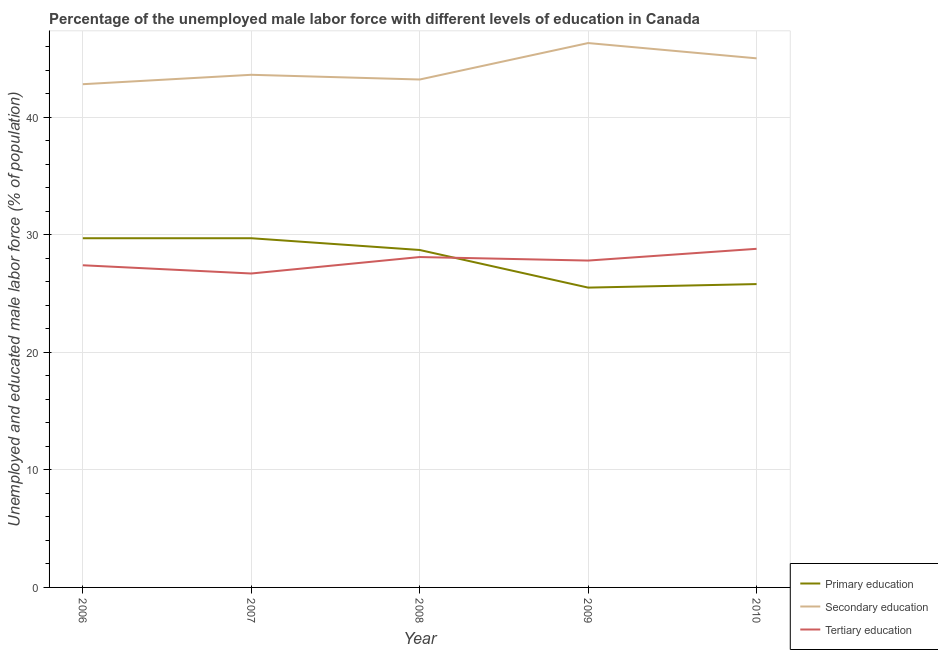How many different coloured lines are there?
Your answer should be very brief. 3. Is the number of lines equal to the number of legend labels?
Your response must be concise. Yes. What is the percentage of male labor force who received tertiary education in 2008?
Give a very brief answer. 28.1. Across all years, what is the maximum percentage of male labor force who received tertiary education?
Your answer should be very brief. 28.8. Across all years, what is the minimum percentage of male labor force who received tertiary education?
Give a very brief answer. 26.7. What is the total percentage of male labor force who received tertiary education in the graph?
Ensure brevity in your answer.  138.8. What is the difference between the percentage of male labor force who received secondary education in 2006 and that in 2007?
Your answer should be very brief. -0.8. What is the difference between the percentage of male labor force who received secondary education in 2007 and the percentage of male labor force who received primary education in 2010?
Give a very brief answer. 17.8. What is the average percentage of male labor force who received tertiary education per year?
Your response must be concise. 27.76. In the year 2010, what is the difference between the percentage of male labor force who received secondary education and percentage of male labor force who received primary education?
Give a very brief answer. 19.2. What is the ratio of the percentage of male labor force who received tertiary education in 2008 to that in 2009?
Your response must be concise. 1.01. Is the percentage of male labor force who received tertiary education in 2006 less than that in 2009?
Provide a short and direct response. Yes. What is the difference between the highest and the second highest percentage of male labor force who received secondary education?
Provide a succinct answer. 1.3. What is the difference between the highest and the lowest percentage of male labor force who received tertiary education?
Your response must be concise. 2.1. Is the sum of the percentage of male labor force who received secondary education in 2008 and 2010 greater than the maximum percentage of male labor force who received tertiary education across all years?
Offer a very short reply. Yes. Is the percentage of male labor force who received tertiary education strictly less than the percentage of male labor force who received primary education over the years?
Keep it short and to the point. No. How many lines are there?
Your answer should be compact. 3. How many years are there in the graph?
Keep it short and to the point. 5. Does the graph contain any zero values?
Your response must be concise. No. How are the legend labels stacked?
Your response must be concise. Vertical. What is the title of the graph?
Ensure brevity in your answer.  Percentage of the unemployed male labor force with different levels of education in Canada. What is the label or title of the X-axis?
Ensure brevity in your answer.  Year. What is the label or title of the Y-axis?
Offer a very short reply. Unemployed and educated male labor force (% of population). What is the Unemployed and educated male labor force (% of population) of Primary education in 2006?
Your answer should be very brief. 29.7. What is the Unemployed and educated male labor force (% of population) of Secondary education in 2006?
Your answer should be very brief. 42.8. What is the Unemployed and educated male labor force (% of population) in Tertiary education in 2006?
Offer a terse response. 27.4. What is the Unemployed and educated male labor force (% of population) of Primary education in 2007?
Your answer should be compact. 29.7. What is the Unemployed and educated male labor force (% of population) in Secondary education in 2007?
Ensure brevity in your answer.  43.6. What is the Unemployed and educated male labor force (% of population) in Tertiary education in 2007?
Ensure brevity in your answer.  26.7. What is the Unemployed and educated male labor force (% of population) of Primary education in 2008?
Give a very brief answer. 28.7. What is the Unemployed and educated male labor force (% of population) in Secondary education in 2008?
Your answer should be compact. 43.2. What is the Unemployed and educated male labor force (% of population) of Tertiary education in 2008?
Offer a terse response. 28.1. What is the Unemployed and educated male labor force (% of population) of Primary education in 2009?
Offer a terse response. 25.5. What is the Unemployed and educated male labor force (% of population) in Secondary education in 2009?
Give a very brief answer. 46.3. What is the Unemployed and educated male labor force (% of population) of Tertiary education in 2009?
Provide a short and direct response. 27.8. What is the Unemployed and educated male labor force (% of population) of Primary education in 2010?
Your answer should be very brief. 25.8. What is the Unemployed and educated male labor force (% of population) in Tertiary education in 2010?
Provide a succinct answer. 28.8. Across all years, what is the maximum Unemployed and educated male labor force (% of population) in Primary education?
Ensure brevity in your answer.  29.7. Across all years, what is the maximum Unemployed and educated male labor force (% of population) in Secondary education?
Provide a succinct answer. 46.3. Across all years, what is the maximum Unemployed and educated male labor force (% of population) of Tertiary education?
Provide a short and direct response. 28.8. Across all years, what is the minimum Unemployed and educated male labor force (% of population) of Secondary education?
Your answer should be very brief. 42.8. Across all years, what is the minimum Unemployed and educated male labor force (% of population) in Tertiary education?
Make the answer very short. 26.7. What is the total Unemployed and educated male labor force (% of population) of Primary education in the graph?
Your answer should be compact. 139.4. What is the total Unemployed and educated male labor force (% of population) of Secondary education in the graph?
Offer a terse response. 220.9. What is the total Unemployed and educated male labor force (% of population) of Tertiary education in the graph?
Offer a very short reply. 138.8. What is the difference between the Unemployed and educated male labor force (% of population) of Secondary education in 2006 and that in 2007?
Your answer should be compact. -0.8. What is the difference between the Unemployed and educated male labor force (% of population) in Secondary education in 2006 and that in 2009?
Ensure brevity in your answer.  -3.5. What is the difference between the Unemployed and educated male labor force (% of population) in Primary education in 2007 and that in 2008?
Provide a succinct answer. 1. What is the difference between the Unemployed and educated male labor force (% of population) in Tertiary education in 2007 and that in 2008?
Make the answer very short. -1.4. What is the difference between the Unemployed and educated male labor force (% of population) in Secondary education in 2007 and that in 2009?
Offer a very short reply. -2.7. What is the difference between the Unemployed and educated male labor force (% of population) of Tertiary education in 2007 and that in 2010?
Your answer should be very brief. -2.1. What is the difference between the Unemployed and educated male labor force (% of population) in Primary education in 2008 and that in 2009?
Give a very brief answer. 3.2. What is the difference between the Unemployed and educated male labor force (% of population) in Tertiary education in 2008 and that in 2009?
Your answer should be compact. 0.3. What is the difference between the Unemployed and educated male labor force (% of population) in Tertiary education in 2008 and that in 2010?
Offer a terse response. -0.7. What is the difference between the Unemployed and educated male labor force (% of population) of Secondary education in 2009 and that in 2010?
Give a very brief answer. 1.3. What is the difference between the Unemployed and educated male labor force (% of population) in Primary education in 2006 and the Unemployed and educated male labor force (% of population) in Tertiary education in 2007?
Offer a very short reply. 3. What is the difference between the Unemployed and educated male labor force (% of population) in Primary education in 2006 and the Unemployed and educated male labor force (% of population) in Secondary education in 2008?
Provide a succinct answer. -13.5. What is the difference between the Unemployed and educated male labor force (% of population) of Primary education in 2006 and the Unemployed and educated male labor force (% of population) of Tertiary education in 2008?
Your answer should be very brief. 1.6. What is the difference between the Unemployed and educated male labor force (% of population) in Secondary education in 2006 and the Unemployed and educated male labor force (% of population) in Tertiary education in 2008?
Your response must be concise. 14.7. What is the difference between the Unemployed and educated male labor force (% of population) of Primary education in 2006 and the Unemployed and educated male labor force (% of population) of Secondary education in 2009?
Give a very brief answer. -16.6. What is the difference between the Unemployed and educated male labor force (% of population) in Primary education in 2006 and the Unemployed and educated male labor force (% of population) in Tertiary education in 2009?
Offer a terse response. 1.9. What is the difference between the Unemployed and educated male labor force (% of population) in Primary education in 2006 and the Unemployed and educated male labor force (% of population) in Secondary education in 2010?
Offer a terse response. -15.3. What is the difference between the Unemployed and educated male labor force (% of population) in Primary education in 2006 and the Unemployed and educated male labor force (% of population) in Tertiary education in 2010?
Your response must be concise. 0.9. What is the difference between the Unemployed and educated male labor force (% of population) in Secondary education in 2007 and the Unemployed and educated male labor force (% of population) in Tertiary education in 2008?
Ensure brevity in your answer.  15.5. What is the difference between the Unemployed and educated male labor force (% of population) in Primary education in 2007 and the Unemployed and educated male labor force (% of population) in Secondary education in 2009?
Keep it short and to the point. -16.6. What is the difference between the Unemployed and educated male labor force (% of population) in Primary education in 2007 and the Unemployed and educated male labor force (% of population) in Tertiary education in 2009?
Your answer should be very brief. 1.9. What is the difference between the Unemployed and educated male labor force (% of population) of Primary education in 2007 and the Unemployed and educated male labor force (% of population) of Secondary education in 2010?
Give a very brief answer. -15.3. What is the difference between the Unemployed and educated male labor force (% of population) in Primary education in 2007 and the Unemployed and educated male labor force (% of population) in Tertiary education in 2010?
Offer a very short reply. 0.9. What is the difference between the Unemployed and educated male labor force (% of population) in Secondary education in 2007 and the Unemployed and educated male labor force (% of population) in Tertiary education in 2010?
Your answer should be compact. 14.8. What is the difference between the Unemployed and educated male labor force (% of population) in Primary education in 2008 and the Unemployed and educated male labor force (% of population) in Secondary education in 2009?
Your answer should be very brief. -17.6. What is the difference between the Unemployed and educated male labor force (% of population) in Primary education in 2008 and the Unemployed and educated male labor force (% of population) in Secondary education in 2010?
Offer a very short reply. -16.3. What is the difference between the Unemployed and educated male labor force (% of population) of Secondary education in 2008 and the Unemployed and educated male labor force (% of population) of Tertiary education in 2010?
Give a very brief answer. 14.4. What is the difference between the Unemployed and educated male labor force (% of population) in Primary education in 2009 and the Unemployed and educated male labor force (% of population) in Secondary education in 2010?
Offer a terse response. -19.5. What is the average Unemployed and educated male labor force (% of population) of Primary education per year?
Offer a very short reply. 27.88. What is the average Unemployed and educated male labor force (% of population) in Secondary education per year?
Keep it short and to the point. 44.18. What is the average Unemployed and educated male labor force (% of population) of Tertiary education per year?
Provide a short and direct response. 27.76. In the year 2006, what is the difference between the Unemployed and educated male labor force (% of population) in Secondary education and Unemployed and educated male labor force (% of population) in Tertiary education?
Offer a terse response. 15.4. In the year 2008, what is the difference between the Unemployed and educated male labor force (% of population) of Primary education and Unemployed and educated male labor force (% of population) of Secondary education?
Make the answer very short. -14.5. In the year 2008, what is the difference between the Unemployed and educated male labor force (% of population) of Primary education and Unemployed and educated male labor force (% of population) of Tertiary education?
Offer a terse response. 0.6. In the year 2008, what is the difference between the Unemployed and educated male labor force (% of population) in Secondary education and Unemployed and educated male labor force (% of population) in Tertiary education?
Offer a terse response. 15.1. In the year 2009, what is the difference between the Unemployed and educated male labor force (% of population) of Primary education and Unemployed and educated male labor force (% of population) of Secondary education?
Provide a succinct answer. -20.8. In the year 2009, what is the difference between the Unemployed and educated male labor force (% of population) of Primary education and Unemployed and educated male labor force (% of population) of Tertiary education?
Give a very brief answer. -2.3. In the year 2010, what is the difference between the Unemployed and educated male labor force (% of population) of Primary education and Unemployed and educated male labor force (% of population) of Secondary education?
Offer a very short reply. -19.2. In the year 2010, what is the difference between the Unemployed and educated male labor force (% of population) in Primary education and Unemployed and educated male labor force (% of population) in Tertiary education?
Provide a succinct answer. -3. In the year 2010, what is the difference between the Unemployed and educated male labor force (% of population) of Secondary education and Unemployed and educated male labor force (% of population) of Tertiary education?
Offer a very short reply. 16.2. What is the ratio of the Unemployed and educated male labor force (% of population) of Primary education in 2006 to that in 2007?
Offer a very short reply. 1. What is the ratio of the Unemployed and educated male labor force (% of population) of Secondary education in 2006 to that in 2007?
Your response must be concise. 0.98. What is the ratio of the Unemployed and educated male labor force (% of population) of Tertiary education in 2006 to that in 2007?
Your answer should be compact. 1.03. What is the ratio of the Unemployed and educated male labor force (% of population) in Primary education in 2006 to that in 2008?
Provide a short and direct response. 1.03. What is the ratio of the Unemployed and educated male labor force (% of population) of Secondary education in 2006 to that in 2008?
Your answer should be very brief. 0.99. What is the ratio of the Unemployed and educated male labor force (% of population) in Tertiary education in 2006 to that in 2008?
Provide a succinct answer. 0.98. What is the ratio of the Unemployed and educated male labor force (% of population) of Primary education in 2006 to that in 2009?
Ensure brevity in your answer.  1.16. What is the ratio of the Unemployed and educated male labor force (% of population) in Secondary education in 2006 to that in 2009?
Your response must be concise. 0.92. What is the ratio of the Unemployed and educated male labor force (% of population) of Tertiary education in 2006 to that in 2009?
Give a very brief answer. 0.99. What is the ratio of the Unemployed and educated male labor force (% of population) in Primary education in 2006 to that in 2010?
Make the answer very short. 1.15. What is the ratio of the Unemployed and educated male labor force (% of population) of Secondary education in 2006 to that in 2010?
Provide a succinct answer. 0.95. What is the ratio of the Unemployed and educated male labor force (% of population) of Tertiary education in 2006 to that in 2010?
Provide a short and direct response. 0.95. What is the ratio of the Unemployed and educated male labor force (% of population) in Primary education in 2007 to that in 2008?
Provide a short and direct response. 1.03. What is the ratio of the Unemployed and educated male labor force (% of population) of Secondary education in 2007 to that in 2008?
Your answer should be compact. 1.01. What is the ratio of the Unemployed and educated male labor force (% of population) in Tertiary education in 2007 to that in 2008?
Your response must be concise. 0.95. What is the ratio of the Unemployed and educated male labor force (% of population) of Primary education in 2007 to that in 2009?
Your response must be concise. 1.16. What is the ratio of the Unemployed and educated male labor force (% of population) of Secondary education in 2007 to that in 2009?
Give a very brief answer. 0.94. What is the ratio of the Unemployed and educated male labor force (% of population) of Tertiary education in 2007 to that in 2009?
Keep it short and to the point. 0.96. What is the ratio of the Unemployed and educated male labor force (% of population) of Primary education in 2007 to that in 2010?
Offer a terse response. 1.15. What is the ratio of the Unemployed and educated male labor force (% of population) of Secondary education in 2007 to that in 2010?
Your answer should be very brief. 0.97. What is the ratio of the Unemployed and educated male labor force (% of population) in Tertiary education in 2007 to that in 2010?
Keep it short and to the point. 0.93. What is the ratio of the Unemployed and educated male labor force (% of population) of Primary education in 2008 to that in 2009?
Offer a very short reply. 1.13. What is the ratio of the Unemployed and educated male labor force (% of population) of Secondary education in 2008 to that in 2009?
Offer a terse response. 0.93. What is the ratio of the Unemployed and educated male labor force (% of population) in Tertiary education in 2008 to that in 2009?
Your answer should be compact. 1.01. What is the ratio of the Unemployed and educated male labor force (% of population) of Primary education in 2008 to that in 2010?
Your response must be concise. 1.11. What is the ratio of the Unemployed and educated male labor force (% of population) of Tertiary education in 2008 to that in 2010?
Offer a very short reply. 0.98. What is the ratio of the Unemployed and educated male labor force (% of population) of Primary education in 2009 to that in 2010?
Give a very brief answer. 0.99. What is the ratio of the Unemployed and educated male labor force (% of population) in Secondary education in 2009 to that in 2010?
Offer a terse response. 1.03. What is the ratio of the Unemployed and educated male labor force (% of population) in Tertiary education in 2009 to that in 2010?
Your answer should be compact. 0.97. What is the difference between the highest and the second highest Unemployed and educated male labor force (% of population) of Primary education?
Give a very brief answer. 0. What is the difference between the highest and the second highest Unemployed and educated male labor force (% of population) of Secondary education?
Give a very brief answer. 1.3. What is the difference between the highest and the second highest Unemployed and educated male labor force (% of population) of Tertiary education?
Your answer should be very brief. 0.7. What is the difference between the highest and the lowest Unemployed and educated male labor force (% of population) in Primary education?
Your answer should be very brief. 4.2. What is the difference between the highest and the lowest Unemployed and educated male labor force (% of population) of Tertiary education?
Ensure brevity in your answer.  2.1. 